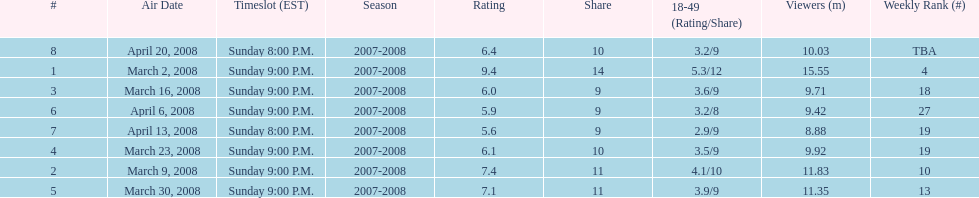What episode had the highest rating? March 2, 2008. 